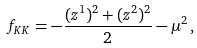<formula> <loc_0><loc_0><loc_500><loc_500>f _ { K K } = - \frac { ( z ^ { 1 } ) ^ { 2 } + ( z ^ { 2 } ) ^ { 2 } } { 2 } - \mu ^ { 2 } \, ,</formula> 